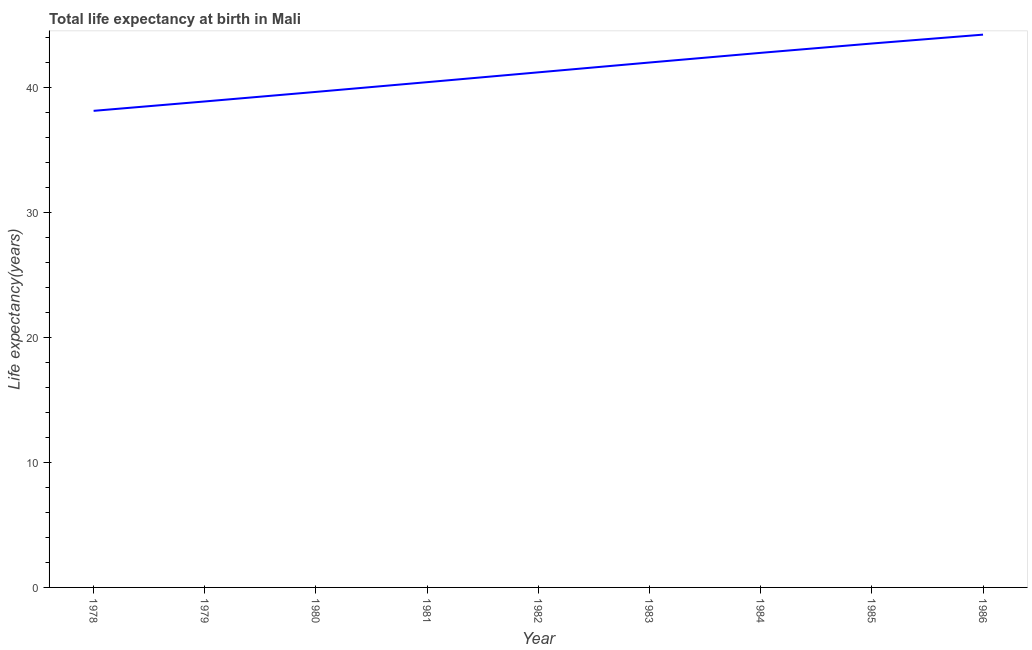What is the life expectancy at birth in 1986?
Your response must be concise. 44.19. Across all years, what is the maximum life expectancy at birth?
Ensure brevity in your answer.  44.19. Across all years, what is the minimum life expectancy at birth?
Provide a succinct answer. 38.1. In which year was the life expectancy at birth minimum?
Ensure brevity in your answer.  1978. What is the sum of the life expectancy at birth?
Provide a succinct answer. 370.5. What is the difference between the life expectancy at birth in 1980 and 1985?
Your answer should be very brief. -3.87. What is the average life expectancy at birth per year?
Offer a very short reply. 41.17. What is the median life expectancy at birth?
Make the answer very short. 41.18. In how many years, is the life expectancy at birth greater than 4 years?
Offer a very short reply. 9. What is the ratio of the life expectancy at birth in 1981 to that in 1986?
Offer a very short reply. 0.91. Is the life expectancy at birth in 1980 less than that in 1981?
Offer a very short reply. Yes. What is the difference between the highest and the second highest life expectancy at birth?
Keep it short and to the point. 0.71. What is the difference between the highest and the lowest life expectancy at birth?
Ensure brevity in your answer.  6.09. Does the life expectancy at birth monotonically increase over the years?
Make the answer very short. Yes. How many lines are there?
Your answer should be very brief. 1. What is the difference between two consecutive major ticks on the Y-axis?
Your response must be concise. 10. Does the graph contain grids?
Offer a terse response. No. What is the title of the graph?
Your answer should be very brief. Total life expectancy at birth in Mali. What is the label or title of the Y-axis?
Provide a succinct answer. Life expectancy(years). What is the Life expectancy(years) of 1978?
Ensure brevity in your answer.  38.1. What is the Life expectancy(years) of 1979?
Your answer should be very brief. 38.85. What is the Life expectancy(years) of 1980?
Provide a succinct answer. 39.61. What is the Life expectancy(years) in 1981?
Keep it short and to the point. 40.39. What is the Life expectancy(years) of 1982?
Your answer should be very brief. 41.18. What is the Life expectancy(years) of 1983?
Keep it short and to the point. 41.96. What is the Life expectancy(years) of 1984?
Provide a succinct answer. 42.73. What is the Life expectancy(years) in 1985?
Offer a very short reply. 43.48. What is the Life expectancy(years) of 1986?
Give a very brief answer. 44.19. What is the difference between the Life expectancy(years) in 1978 and 1979?
Give a very brief answer. -0.75. What is the difference between the Life expectancy(years) in 1978 and 1980?
Offer a terse response. -1.51. What is the difference between the Life expectancy(years) in 1978 and 1981?
Your response must be concise. -2.29. What is the difference between the Life expectancy(years) in 1978 and 1982?
Make the answer very short. -3.08. What is the difference between the Life expectancy(years) in 1978 and 1983?
Provide a succinct answer. -3.86. What is the difference between the Life expectancy(years) in 1978 and 1984?
Provide a short and direct response. -4.64. What is the difference between the Life expectancy(years) in 1978 and 1985?
Give a very brief answer. -5.38. What is the difference between the Life expectancy(years) in 1978 and 1986?
Ensure brevity in your answer.  -6.09. What is the difference between the Life expectancy(years) in 1979 and 1980?
Keep it short and to the point. -0.76. What is the difference between the Life expectancy(years) in 1979 and 1981?
Your answer should be very brief. -1.54. What is the difference between the Life expectancy(years) in 1979 and 1982?
Ensure brevity in your answer.  -2.33. What is the difference between the Life expectancy(years) in 1979 and 1983?
Your answer should be very brief. -3.11. What is the difference between the Life expectancy(years) in 1979 and 1984?
Provide a short and direct response. -3.89. What is the difference between the Life expectancy(years) in 1979 and 1985?
Make the answer very short. -4.63. What is the difference between the Life expectancy(years) in 1979 and 1986?
Provide a short and direct response. -5.34. What is the difference between the Life expectancy(years) in 1980 and 1981?
Provide a succinct answer. -0.78. What is the difference between the Life expectancy(years) in 1980 and 1982?
Your answer should be very brief. -1.56. What is the difference between the Life expectancy(years) in 1980 and 1983?
Provide a short and direct response. -2.35. What is the difference between the Life expectancy(years) in 1980 and 1984?
Provide a succinct answer. -3.12. What is the difference between the Life expectancy(years) in 1980 and 1985?
Offer a terse response. -3.87. What is the difference between the Life expectancy(years) in 1980 and 1986?
Keep it short and to the point. -4.58. What is the difference between the Life expectancy(years) in 1981 and 1982?
Offer a very short reply. -0.79. What is the difference between the Life expectancy(years) in 1981 and 1983?
Your response must be concise. -1.57. What is the difference between the Life expectancy(years) in 1981 and 1984?
Provide a short and direct response. -2.34. What is the difference between the Life expectancy(years) in 1981 and 1985?
Your answer should be compact. -3.09. What is the difference between the Life expectancy(years) in 1981 and 1986?
Keep it short and to the point. -3.8. What is the difference between the Life expectancy(years) in 1982 and 1983?
Provide a succinct answer. -0.78. What is the difference between the Life expectancy(years) in 1982 and 1984?
Ensure brevity in your answer.  -1.56. What is the difference between the Life expectancy(years) in 1982 and 1985?
Keep it short and to the point. -2.3. What is the difference between the Life expectancy(years) in 1982 and 1986?
Ensure brevity in your answer.  -3.01. What is the difference between the Life expectancy(years) in 1983 and 1984?
Keep it short and to the point. -0.77. What is the difference between the Life expectancy(years) in 1983 and 1985?
Keep it short and to the point. -1.52. What is the difference between the Life expectancy(years) in 1983 and 1986?
Your response must be concise. -2.23. What is the difference between the Life expectancy(years) in 1984 and 1985?
Your answer should be very brief. -0.75. What is the difference between the Life expectancy(years) in 1984 and 1986?
Your response must be concise. -1.46. What is the difference between the Life expectancy(years) in 1985 and 1986?
Give a very brief answer. -0.71. What is the ratio of the Life expectancy(years) in 1978 to that in 1979?
Provide a short and direct response. 0.98. What is the ratio of the Life expectancy(years) in 1978 to that in 1981?
Your response must be concise. 0.94. What is the ratio of the Life expectancy(years) in 1978 to that in 1982?
Your response must be concise. 0.93. What is the ratio of the Life expectancy(years) in 1978 to that in 1983?
Your answer should be very brief. 0.91. What is the ratio of the Life expectancy(years) in 1978 to that in 1984?
Provide a succinct answer. 0.89. What is the ratio of the Life expectancy(years) in 1978 to that in 1985?
Your answer should be very brief. 0.88. What is the ratio of the Life expectancy(years) in 1978 to that in 1986?
Your answer should be very brief. 0.86. What is the ratio of the Life expectancy(years) in 1979 to that in 1980?
Provide a short and direct response. 0.98. What is the ratio of the Life expectancy(years) in 1979 to that in 1981?
Your answer should be very brief. 0.96. What is the ratio of the Life expectancy(years) in 1979 to that in 1982?
Ensure brevity in your answer.  0.94. What is the ratio of the Life expectancy(years) in 1979 to that in 1983?
Keep it short and to the point. 0.93. What is the ratio of the Life expectancy(years) in 1979 to that in 1984?
Offer a terse response. 0.91. What is the ratio of the Life expectancy(years) in 1979 to that in 1985?
Your response must be concise. 0.89. What is the ratio of the Life expectancy(years) in 1979 to that in 1986?
Ensure brevity in your answer.  0.88. What is the ratio of the Life expectancy(years) in 1980 to that in 1983?
Provide a short and direct response. 0.94. What is the ratio of the Life expectancy(years) in 1980 to that in 1984?
Your answer should be compact. 0.93. What is the ratio of the Life expectancy(years) in 1980 to that in 1985?
Give a very brief answer. 0.91. What is the ratio of the Life expectancy(years) in 1980 to that in 1986?
Your answer should be compact. 0.9. What is the ratio of the Life expectancy(years) in 1981 to that in 1983?
Your answer should be compact. 0.96. What is the ratio of the Life expectancy(years) in 1981 to that in 1984?
Provide a succinct answer. 0.94. What is the ratio of the Life expectancy(years) in 1981 to that in 1985?
Make the answer very short. 0.93. What is the ratio of the Life expectancy(years) in 1981 to that in 1986?
Ensure brevity in your answer.  0.91. What is the ratio of the Life expectancy(years) in 1982 to that in 1983?
Offer a terse response. 0.98. What is the ratio of the Life expectancy(years) in 1982 to that in 1984?
Provide a succinct answer. 0.96. What is the ratio of the Life expectancy(years) in 1982 to that in 1985?
Make the answer very short. 0.95. What is the ratio of the Life expectancy(years) in 1982 to that in 1986?
Provide a short and direct response. 0.93. What is the ratio of the Life expectancy(years) in 1983 to that in 1985?
Keep it short and to the point. 0.96. What is the ratio of the Life expectancy(years) in 1984 to that in 1986?
Your answer should be compact. 0.97. What is the ratio of the Life expectancy(years) in 1985 to that in 1986?
Keep it short and to the point. 0.98. 